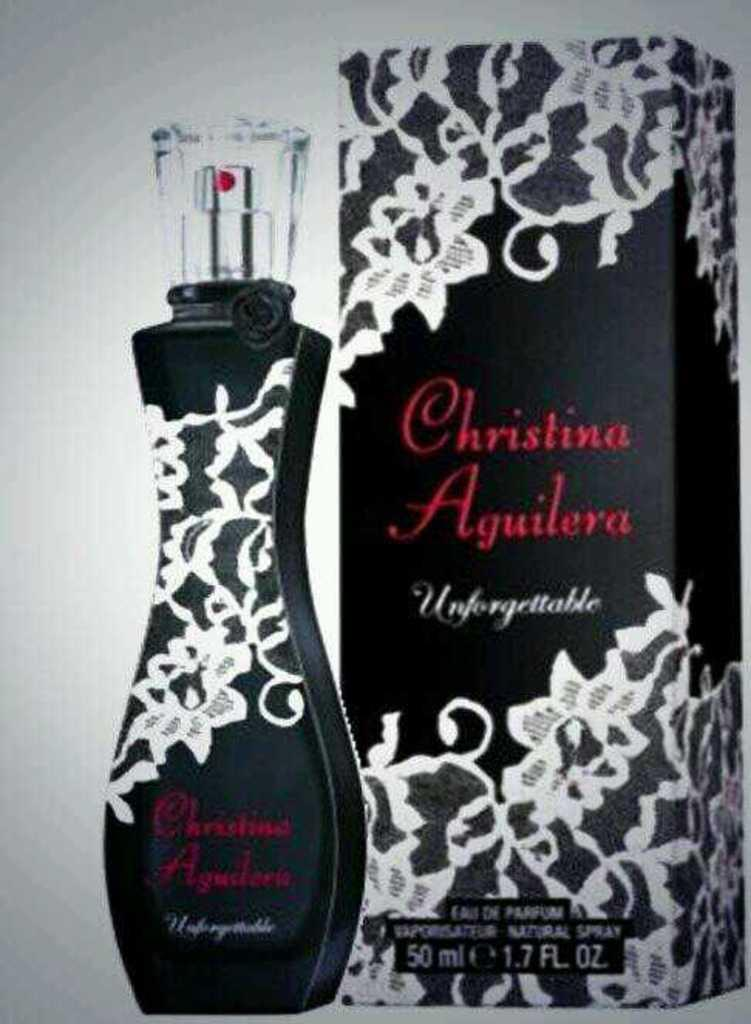Provide a one-sentence caption for the provided image. Christina Aguilera perfume standing next to same box. 